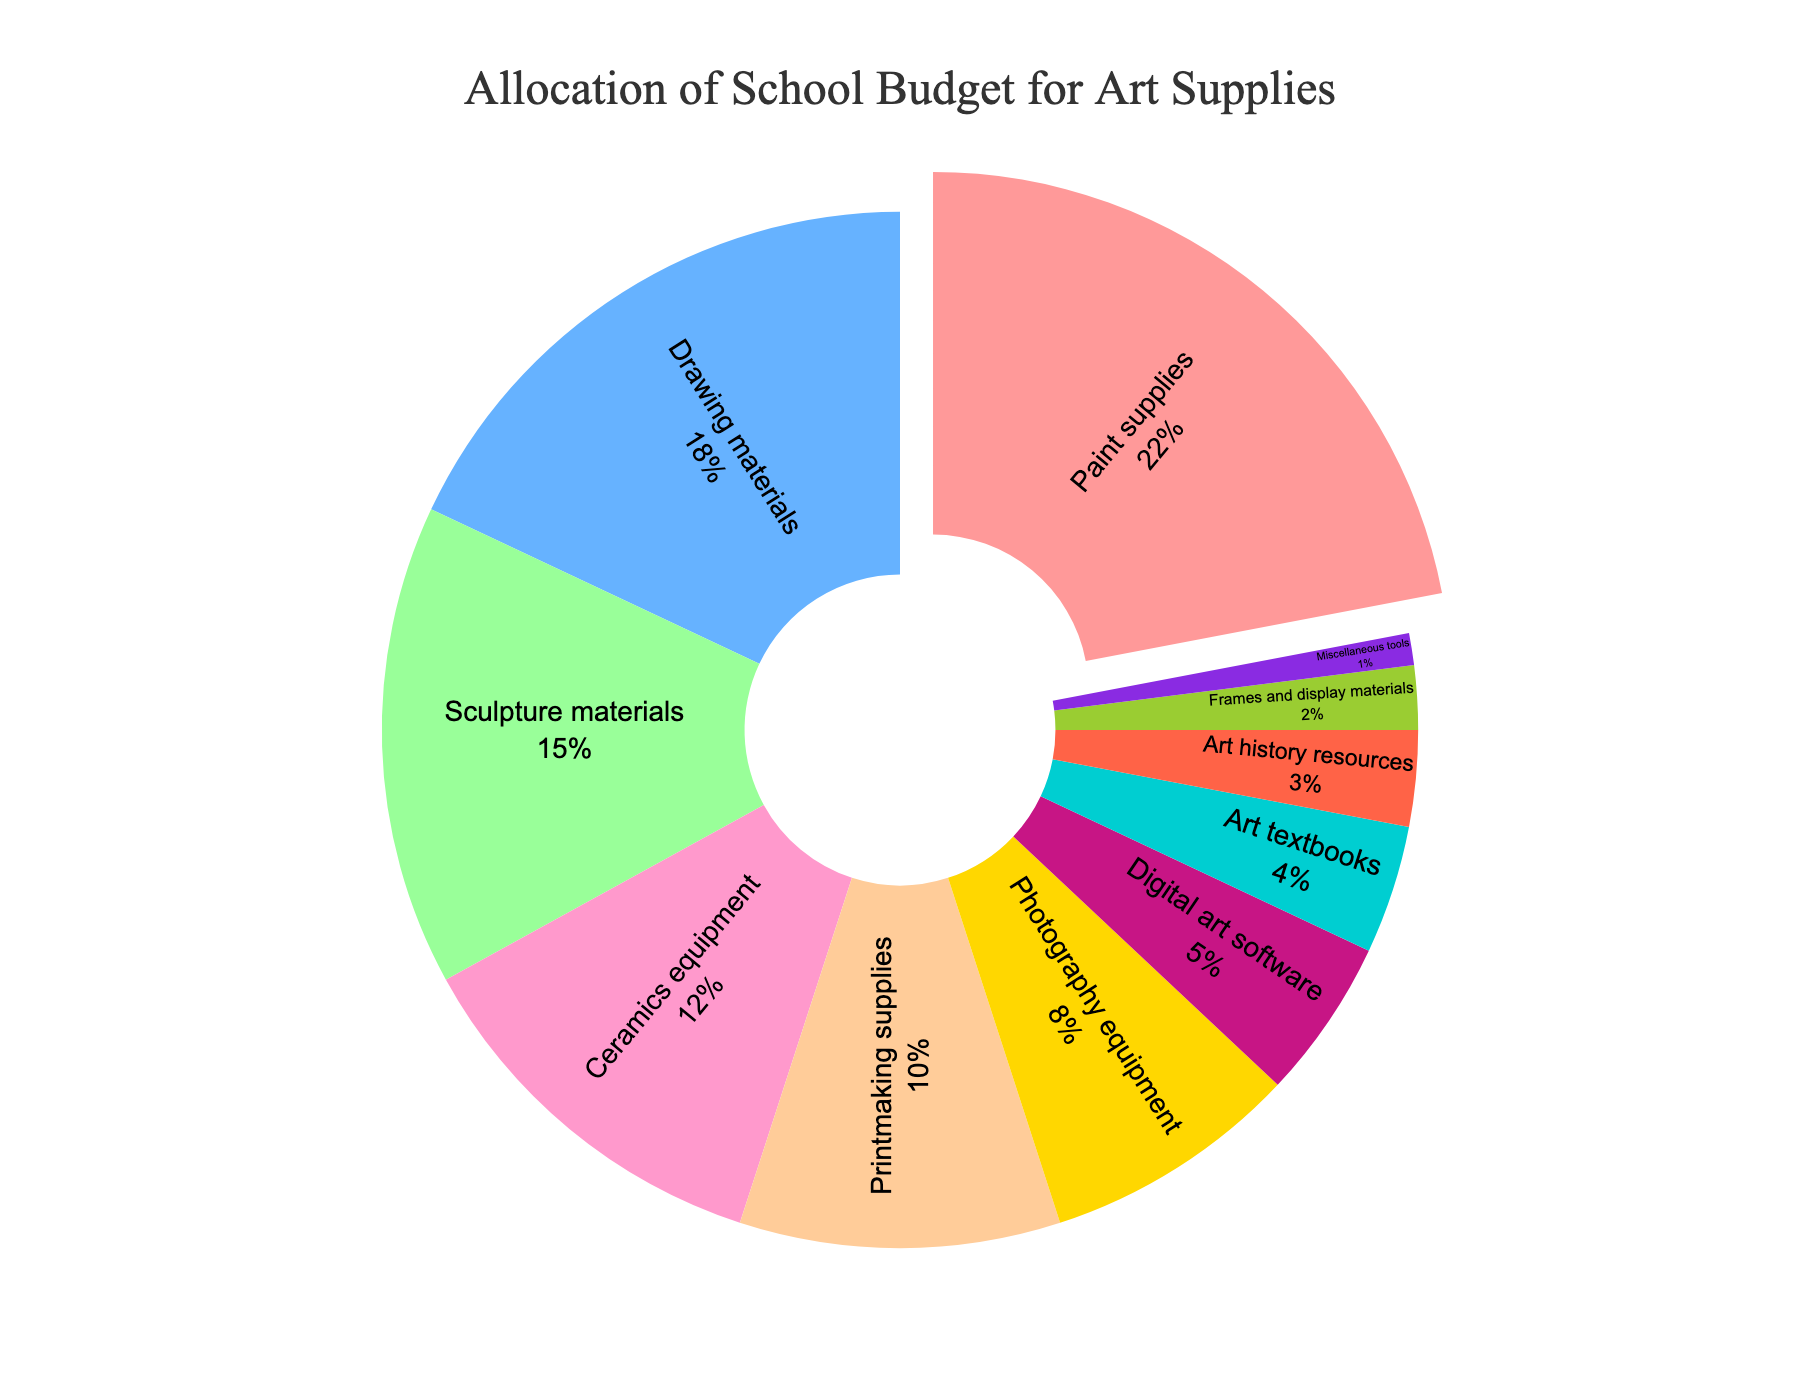What's the largest category in the budget allocation? The largest category is indicated by the section that occupies the largest area in the pie chart. By visual inspection, the "Paint supplies" category is the largest.
Answer: Paint supplies What is the combined percentage of budget allocation for Drawing materials and Sculpture materials? To find the combined percentage, add the percentage of the "Drawing materials" category and the "Sculpture materials" category: 18% + 15% = 33%.
Answer: 33% Which category has a smaller budget: Photography equipment or Digital art software? By comparing the sections of "Photography equipment" and "Digital art software", it's clear that "Digital art software" is smaller.
Answer: Digital art software How much more budget does Paint supplies receive compared to Printmaking supplies? Subtract the percentage of "Printmaking supplies" from the "Paint supplies": 22% - 10% = 12%.
Answer: 12% If the categories with the smallest allocation (Miscellaneous tools, Frames and display materials, and Art history resources) are combined, what percentage of the budget do they represent? Sum the percentages of "Miscellaneous tools", "Frames and display materials", and "Art history resources": 1% + 2% + 3% = 6%.
Answer: 6% Which category receives a budget that is closest to 10%? By visual inspection, the "Printmaking supplies" category receives exactly 10% of the budget.
Answer: Printmaking supplies Are the Ceramics equipment and Photography equipment budget allocations greater than 15% combined? Add the percentages of "Ceramics equipment" and "Photography equipment": 12% + 8% = 20%, which is greater than 15%.
Answer: Yes What percentage of the budget is allocated to categories related to digital art (Digital art software and Photography equipment)? Sum the percentages of "Digital art software" and "Photography equipment": 5% + 8% = 13%.
Answer: 13% Which two categories, when combined, have a budget allocation equal to Paint supplies? By finding two categories whose combined percentage equals 22%, we can pair "Drawing materials" (18%) and "Art textbooks" (4%): 18% + 4% = 22%.
Answer: Drawing materials and Art textbooks What is the difference between the budget allocations for Sculpture materials and Art history resources? Subtract the percentage of "Art history resources" from "Sculpture materials": 15% - 3% = 12%.
Answer: 12% 